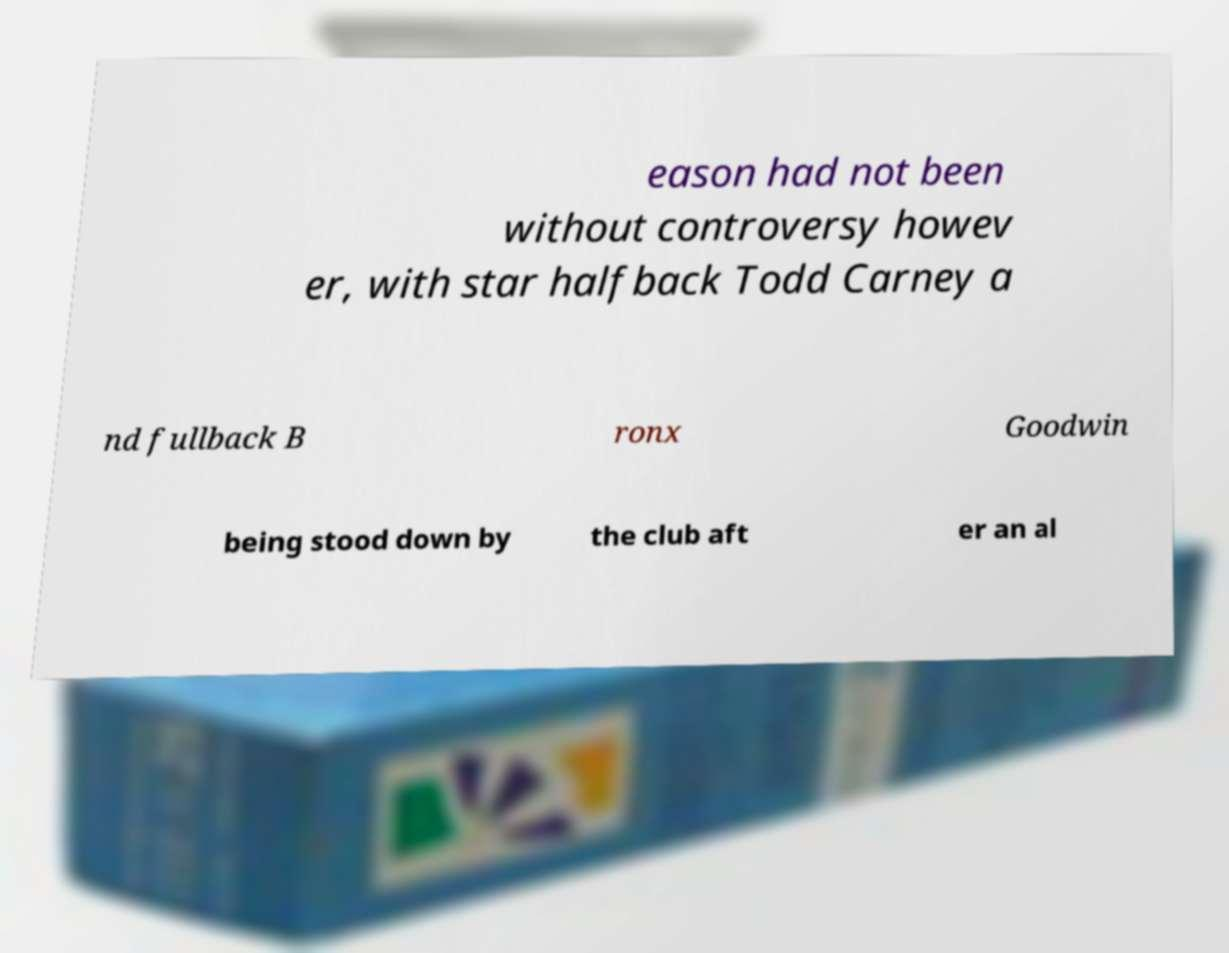Can you read and provide the text displayed in the image?This photo seems to have some interesting text. Can you extract and type it out for me? eason had not been without controversy howev er, with star halfback Todd Carney a nd fullback B ronx Goodwin being stood down by the club aft er an al 